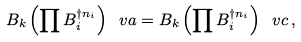<formula> <loc_0><loc_0><loc_500><loc_500>B _ { k } \left ( \prod B _ { i } ^ { \dagger n _ { i } } \right ) \ v a = B _ { k } \left ( \prod B _ { i } ^ { \dagger n _ { i } } \right ) \ v c \, ,</formula> 